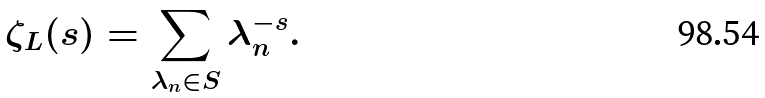<formula> <loc_0><loc_0><loc_500><loc_500>\zeta _ { L } ( s ) = \sum _ { \lambda _ { n } \in S } \lambda _ { n } ^ { - s } .</formula> 